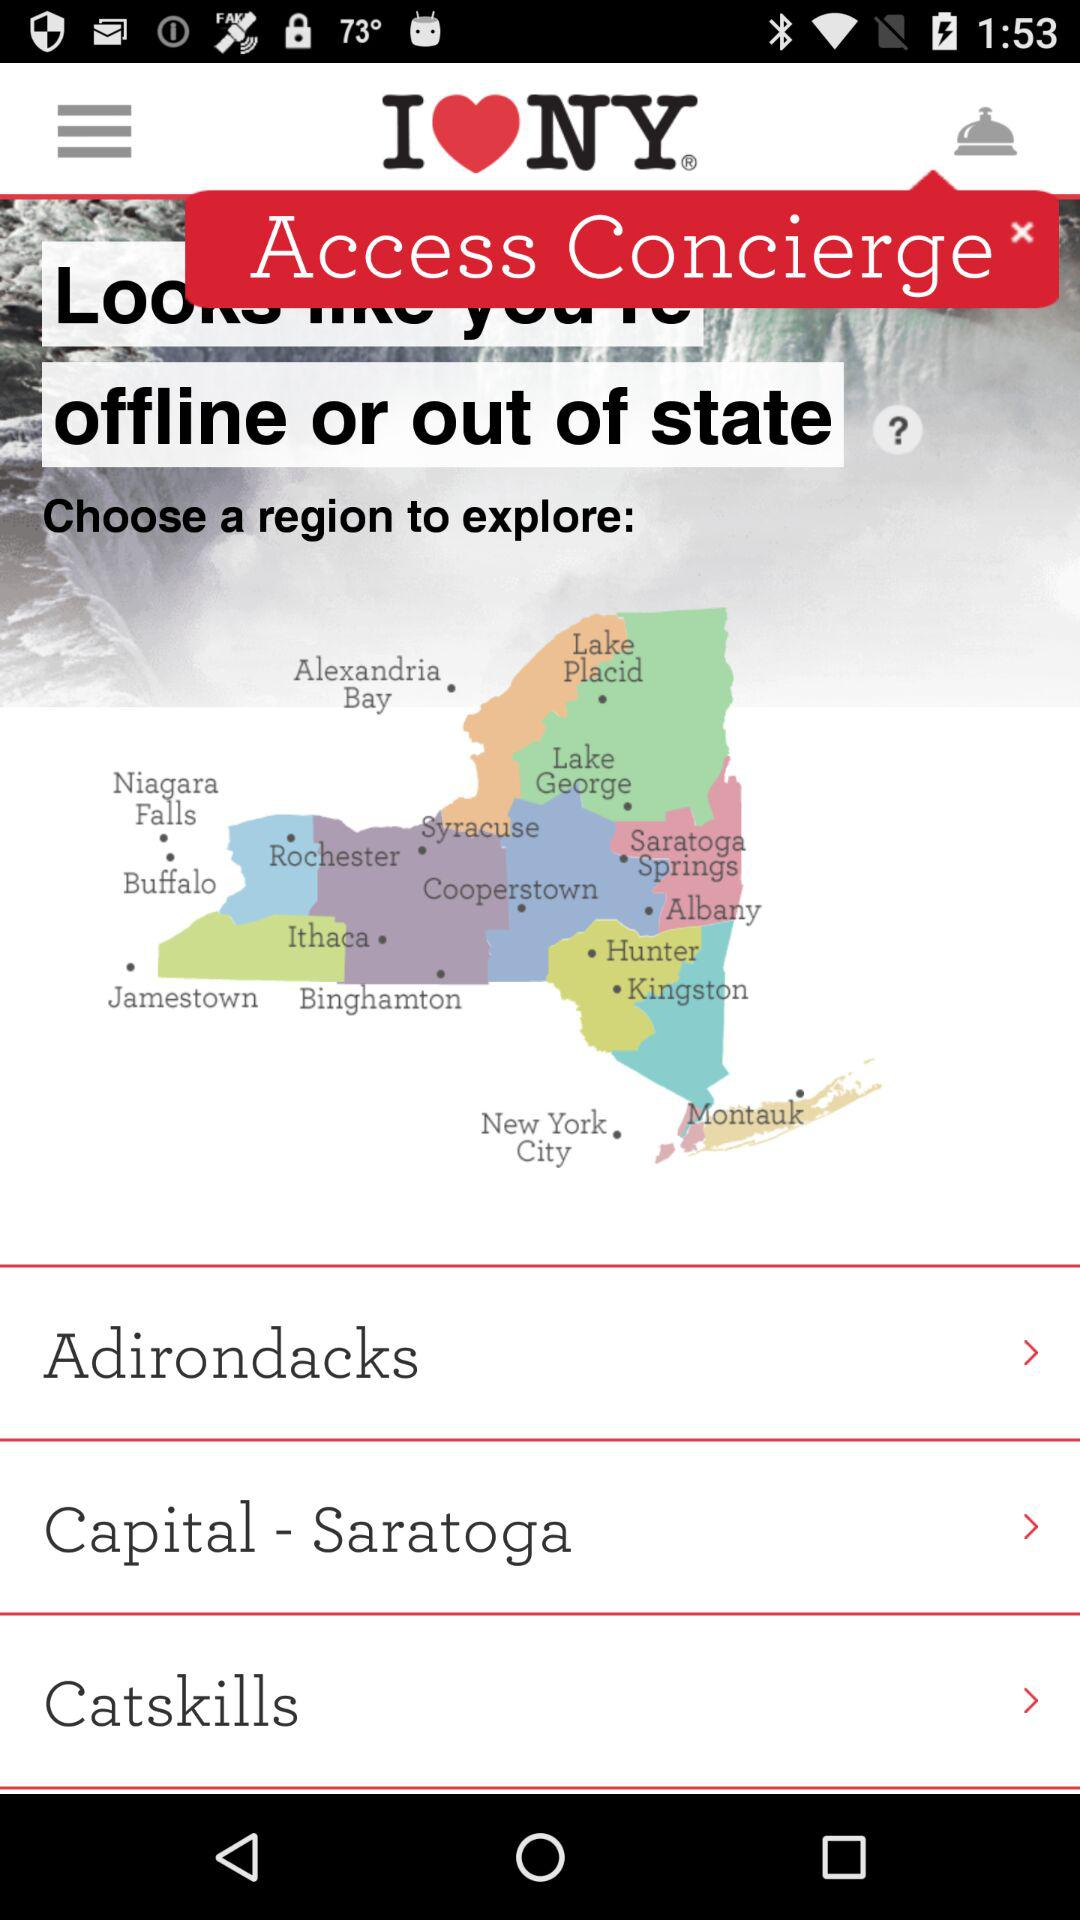How many people live in NY?
When the provided information is insufficient, respond with <no answer>. <no answer> 